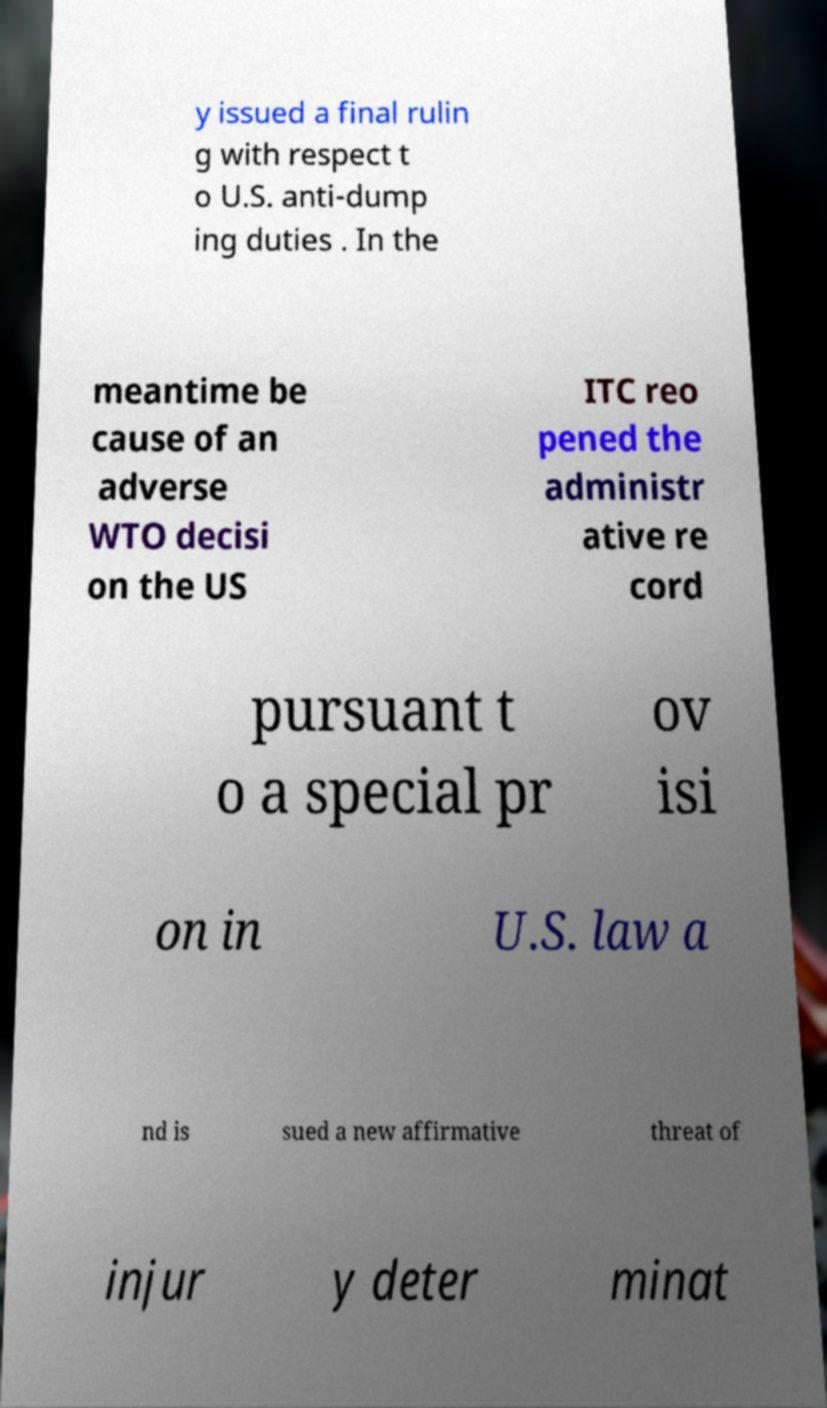What messages or text are displayed in this image? I need them in a readable, typed format. y issued a final rulin g with respect t o U.S. anti-dump ing duties . In the meantime be cause of an adverse WTO decisi on the US ITC reo pened the administr ative re cord pursuant t o a special pr ov isi on in U.S. law a nd is sued a new affirmative threat of injur y deter minat 